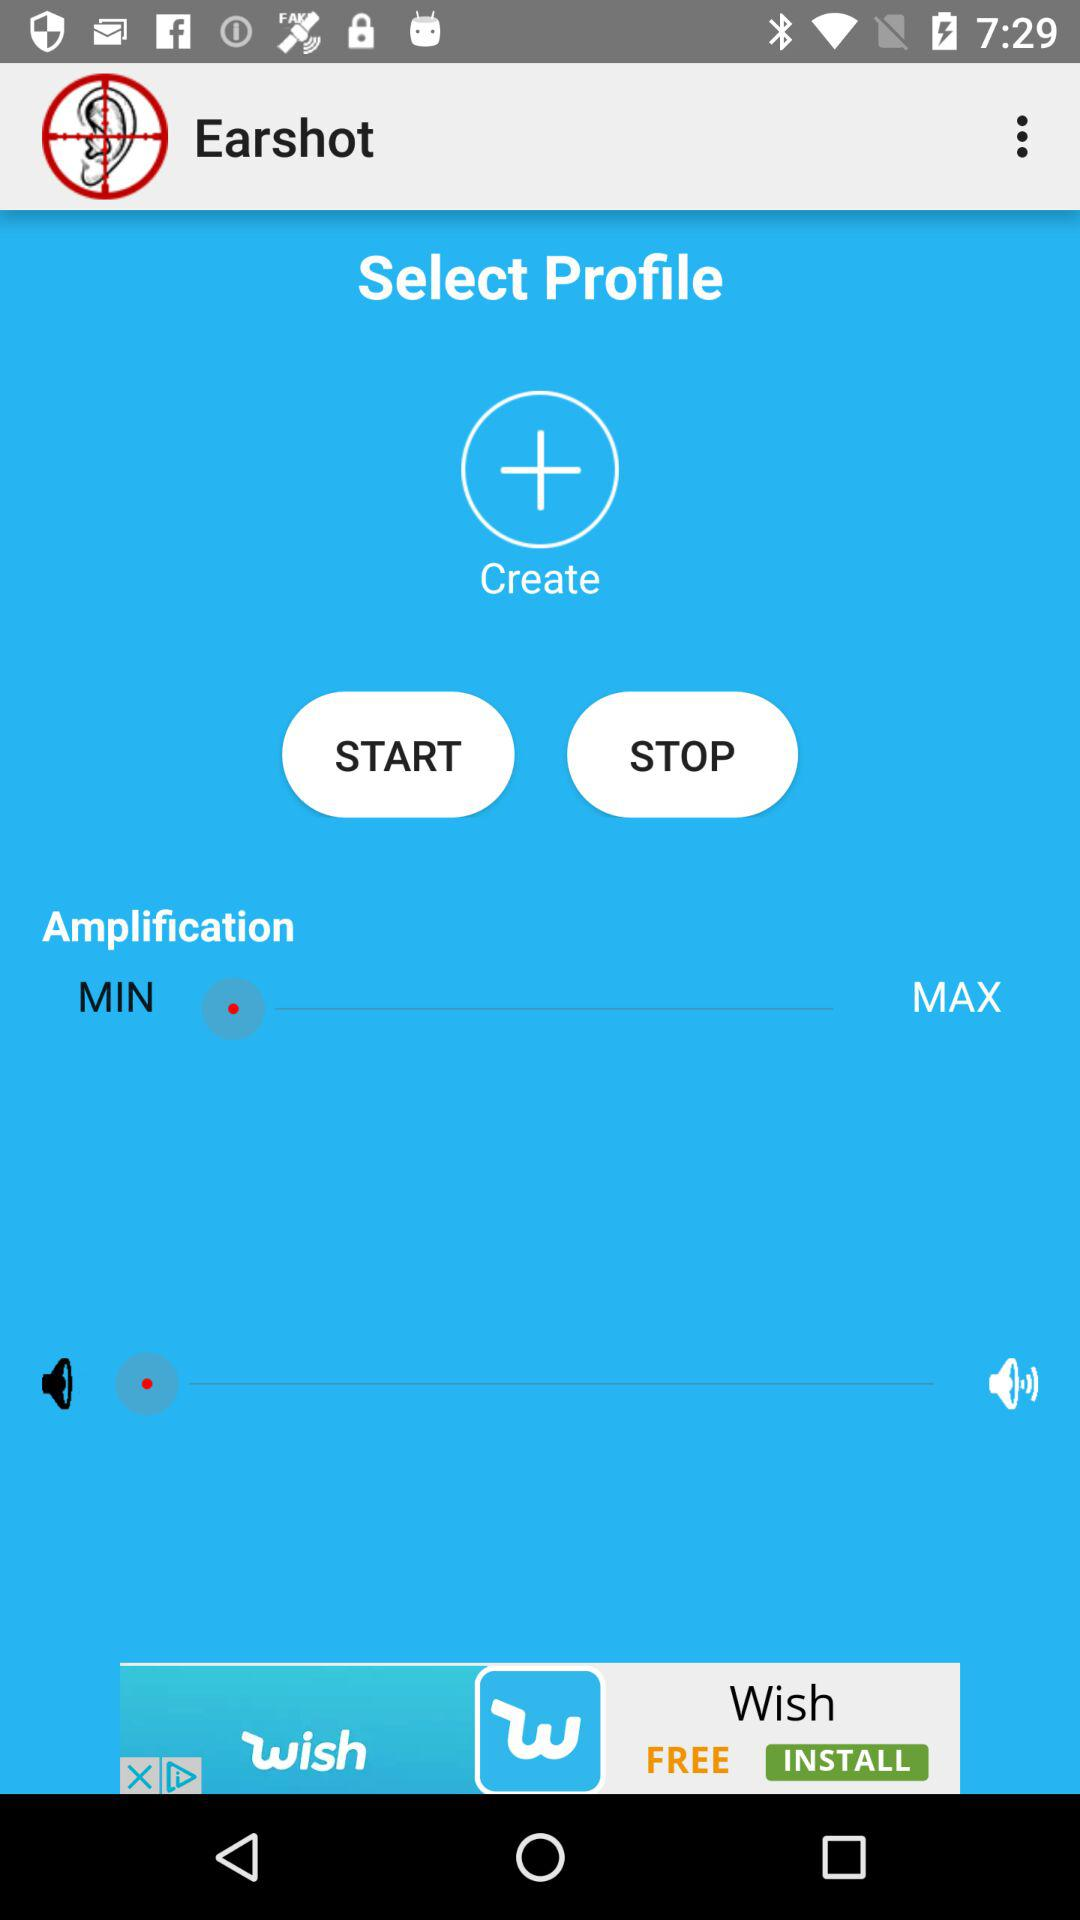What is the name of the application? The name of the application is "Earshot". 